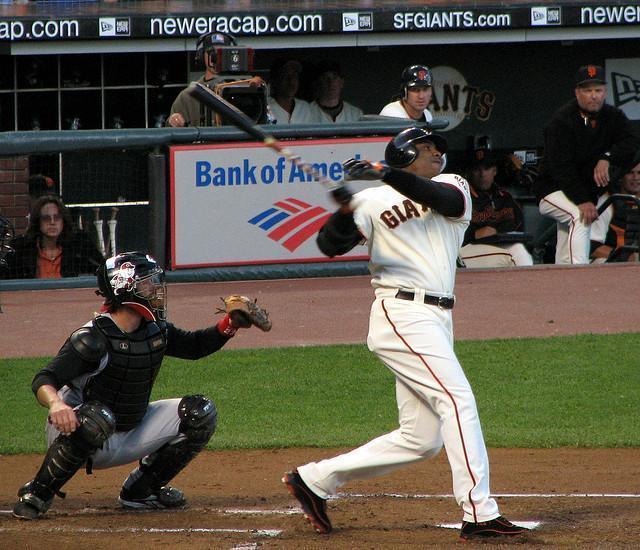How many people are in the photo?
Give a very brief answer. 6. How many people are using backpacks or bags?
Give a very brief answer. 0. 